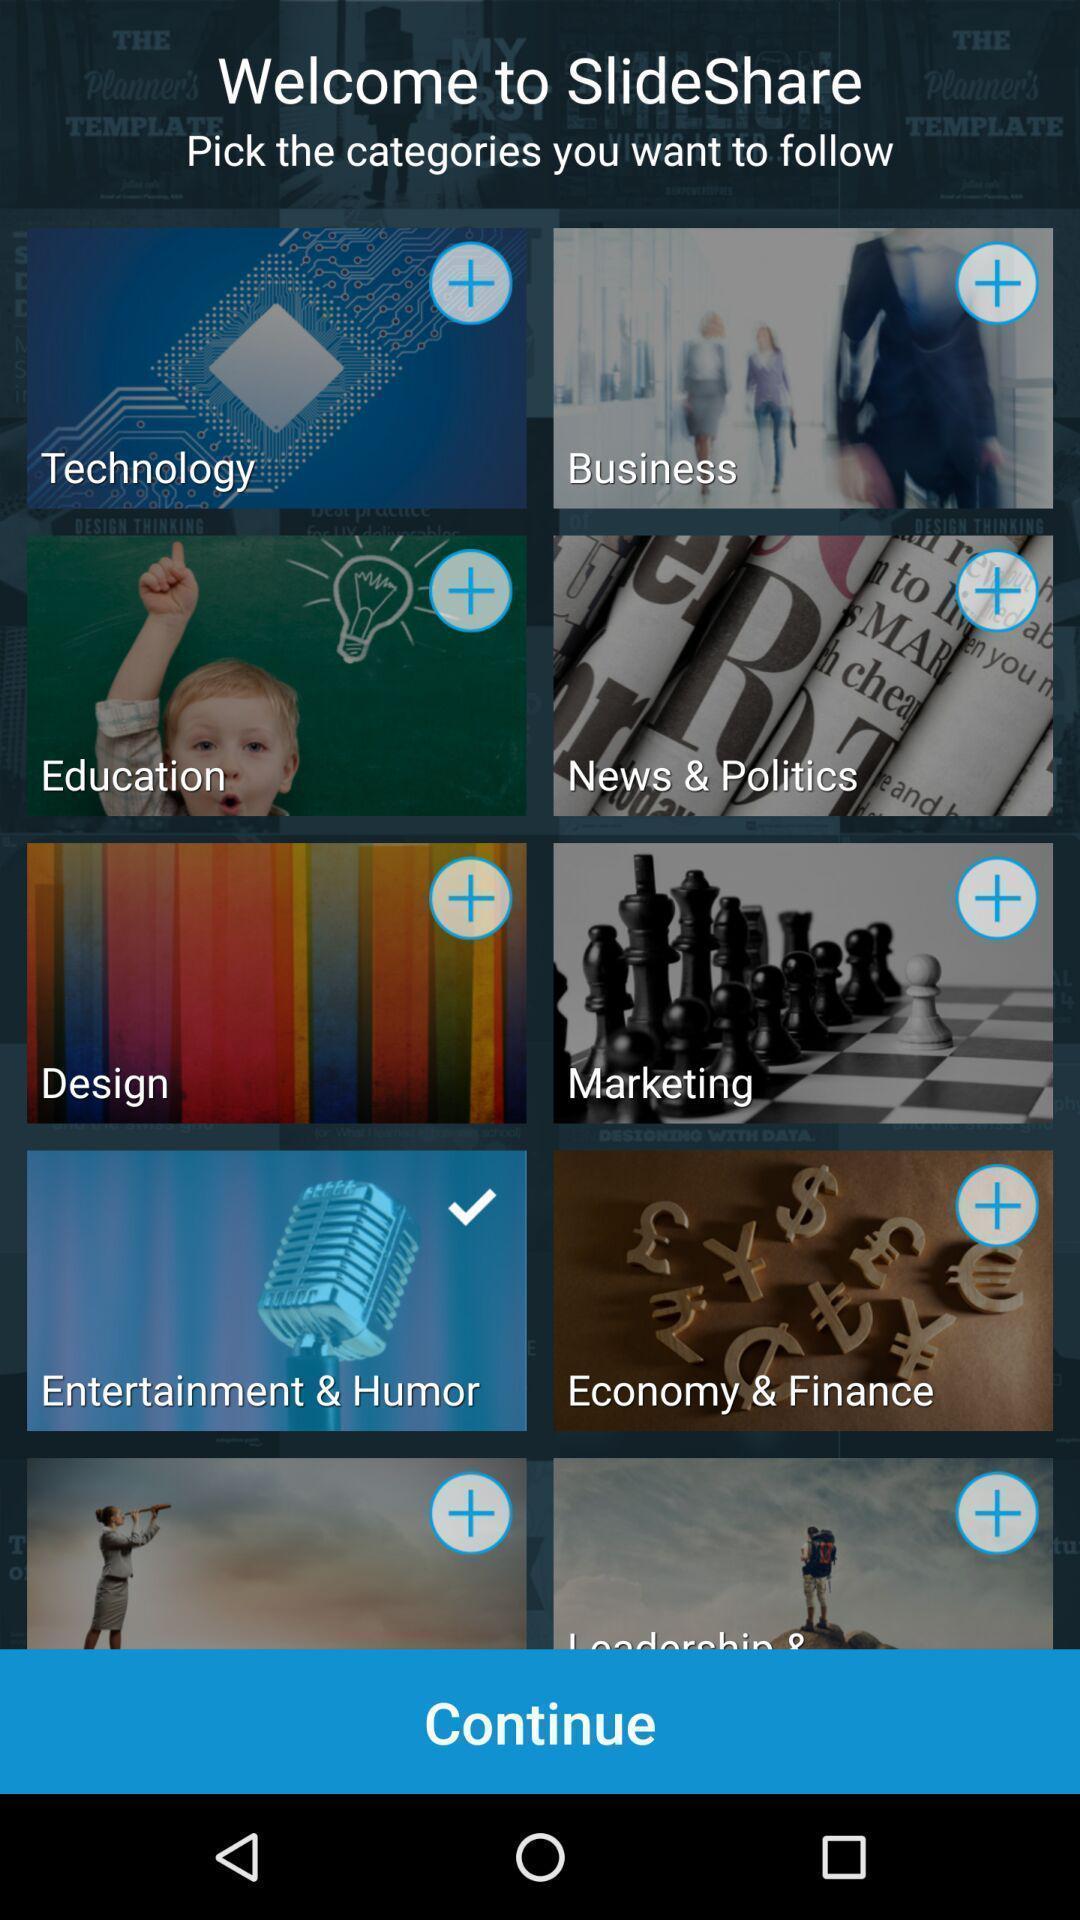Describe the content in this image. Welcome page of photo share app. 